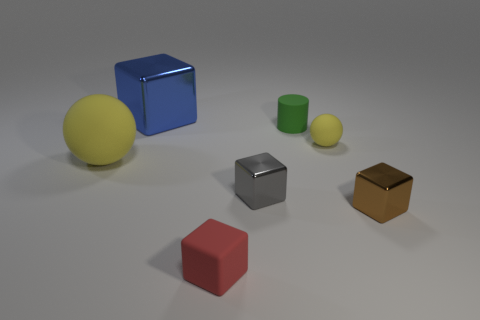Subtract all tiny red rubber cubes. How many cubes are left? 3 Add 1 large green rubber things. How many objects exist? 8 Subtract all balls. How many objects are left? 5 Subtract all blue blocks. How many blocks are left? 3 Subtract 1 cylinders. How many cylinders are left? 0 Subtract all blue cylinders. Subtract all gray balls. How many cylinders are left? 1 Subtract all tiny rubber spheres. Subtract all tiny brown shiny things. How many objects are left? 5 Add 1 tiny yellow balls. How many tiny yellow balls are left? 2 Add 6 metallic cylinders. How many metallic cylinders exist? 6 Subtract 0 yellow cubes. How many objects are left? 7 